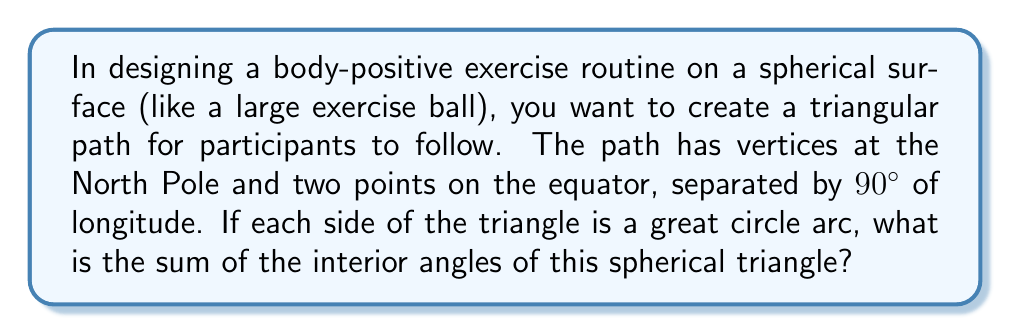Provide a solution to this math problem. Let's approach this step-by-step:

1) In spherical geometry, we're working on the surface of a sphere. The lines (geodesics) on this surface are great circle arcs.

2) We have a triangle with vertices:
   - A: North Pole
   - B: A point on the equator
   - C: Another point on the equator, 90° of longitude away from B

3) In spherical geometry, the sum of angles in a triangle is always greater than 180°. The excess over 180° is called the spherical excess, denoted by $E$.

4) The formula for spherical excess is:

   $$E = A + B + C - 180°$$

   where $A$, $B$, and $C$ are the angles of the spherical triangle in degrees.

5) In our case:
   - Angle A (at the North Pole) is 90° because the other two vertices are on the equator.
   - Angles B and C are both 90° because they're formed by a meridian (line of longitude) meeting the equator.

6) Therefore, the sum of the angles is:

   $$90° + 90° + 90° = 270°$$

7) The spherical excess is:

   $$E = 270° - 180° = 90°$$

This means our spherical triangle has 90° more than a planar triangle.
Answer: 270° 